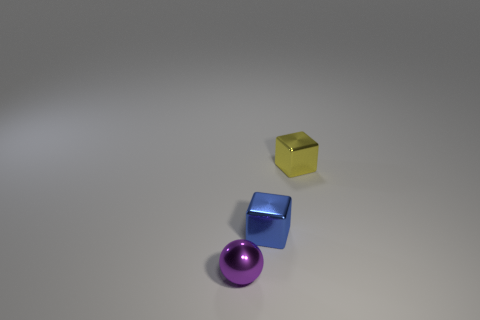Add 1 blue rubber objects. How many objects exist? 4 Subtract all spheres. How many objects are left? 2 Add 3 blue shiny blocks. How many blue shiny blocks are left? 4 Add 2 red matte cubes. How many red matte cubes exist? 2 Subtract 0 brown spheres. How many objects are left? 3 Subtract all small blue blocks. Subtract all purple metallic spheres. How many objects are left? 1 